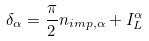<formula> <loc_0><loc_0><loc_500><loc_500>\delta _ { \alpha } = \frac { \pi } { 2 } n _ { i m p , \alpha } + I _ { L } ^ { \alpha }</formula> 